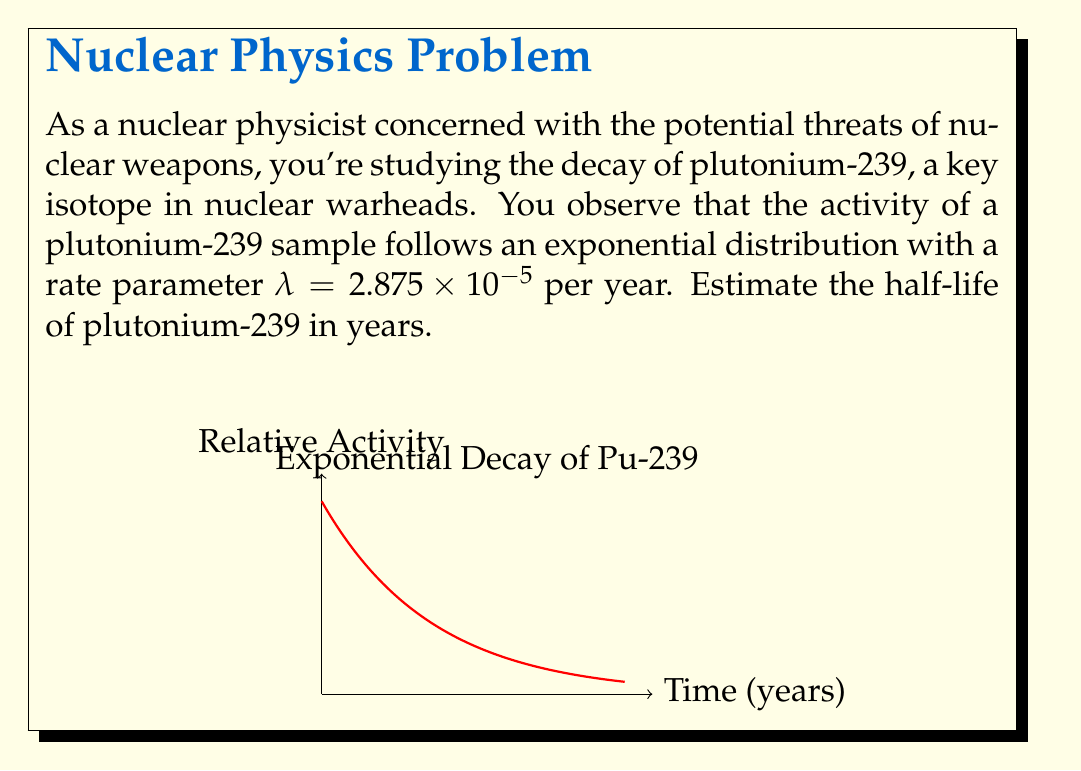Provide a solution to this math problem. To solve this problem, we'll use the properties of exponential distribution and the definition of half-life:

1) The exponential distribution for radioactive decay is given by:

   $$A(t) = A_0 e^{-λt}$$

   where $A(t)$ is the activity at time $t$, $A_0$ is the initial activity, and $λ$ is the decay constant.

2) The half-life $t_{1/2}$ is the time it takes for the activity to reduce to half its initial value:

   $$\frac{1}{2} = e^{-λt_{1/2}}$$

3) Taking the natural logarithm of both sides:

   $$\ln(\frac{1}{2}) = -λt_{1/2}$$

4) Solving for $t_{1/2}$:

   $$t_{1/2} = -\frac{\ln(\frac{1}{2})}{λ} = \frac{\ln(2)}{λ}$$

5) Substituting the given value of λ = 2.875 × 10^(-5) per year:

   $$t_{1/2} = \frac{\ln(2)}{2.875 \times 10^{-5}} \approx 24110.25 \text{ years}$$

6) Rounding to the nearest year:

   $$t_{1/2} \approx 24110 \text{ years}$$
Answer: 24110 years 